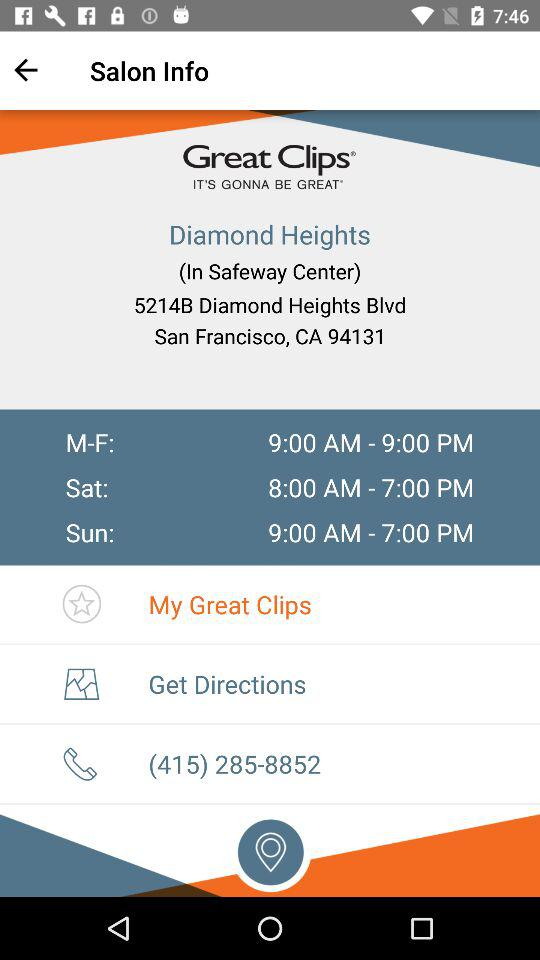What is the salon name? The salon name is "Great Clips". 